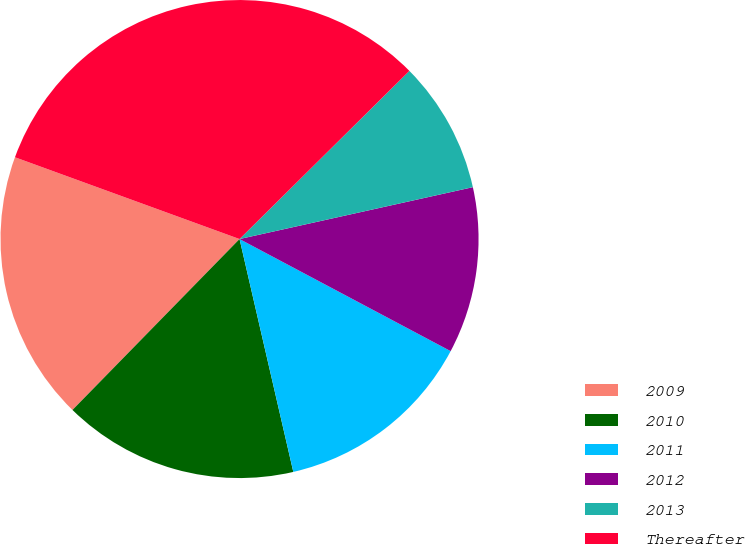<chart> <loc_0><loc_0><loc_500><loc_500><pie_chart><fcel>2009<fcel>2010<fcel>2011<fcel>2012<fcel>2013<fcel>Thereafter<nl><fcel>18.24%<fcel>15.93%<fcel>13.62%<fcel>11.25%<fcel>8.94%<fcel>32.02%<nl></chart> 